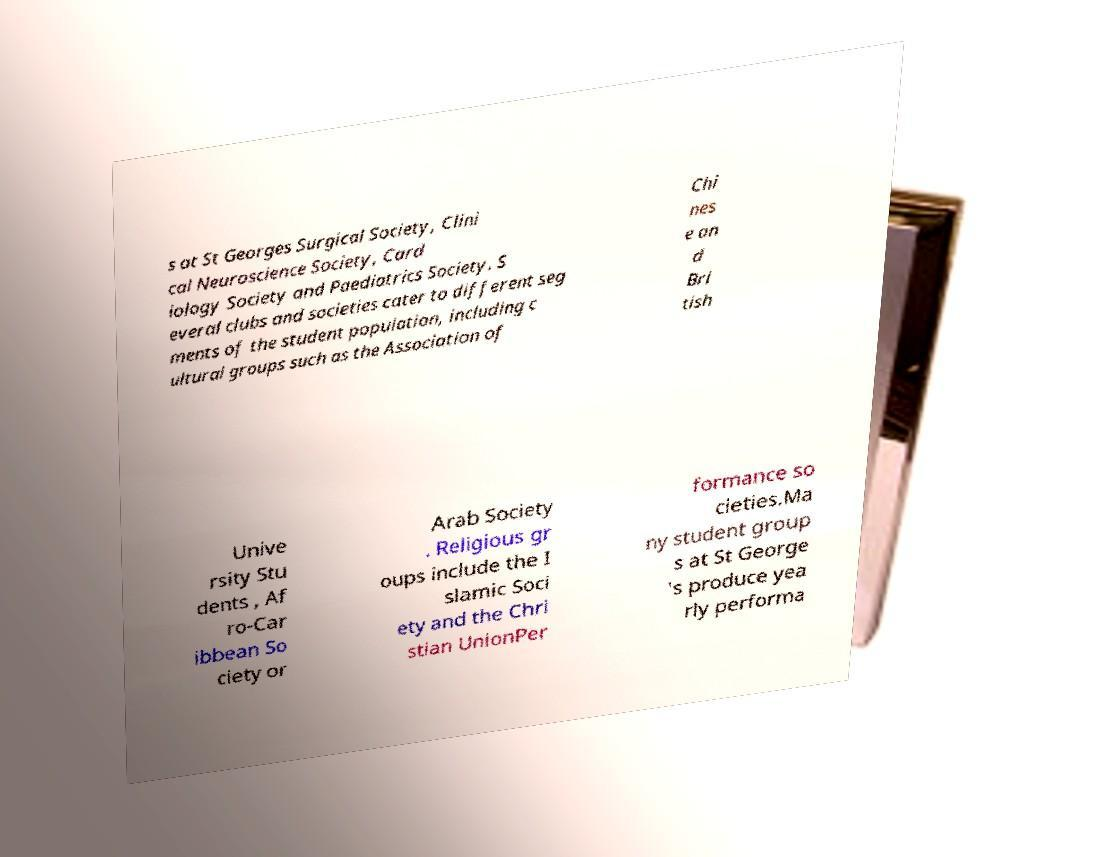Please read and relay the text visible in this image. What does it say? s at St Georges Surgical Society, Clini cal Neuroscience Society, Card iology Society and Paediatrics Society. S everal clubs and societies cater to different seg ments of the student population, including c ultural groups such as the Association of Chi nes e an d Bri tish Unive rsity Stu dents , Af ro-Car ibbean So ciety or Arab Society . Religious gr oups include the I slamic Soci ety and the Chri stian UnionPer formance so cieties.Ma ny student group s at St George 's produce yea rly performa 